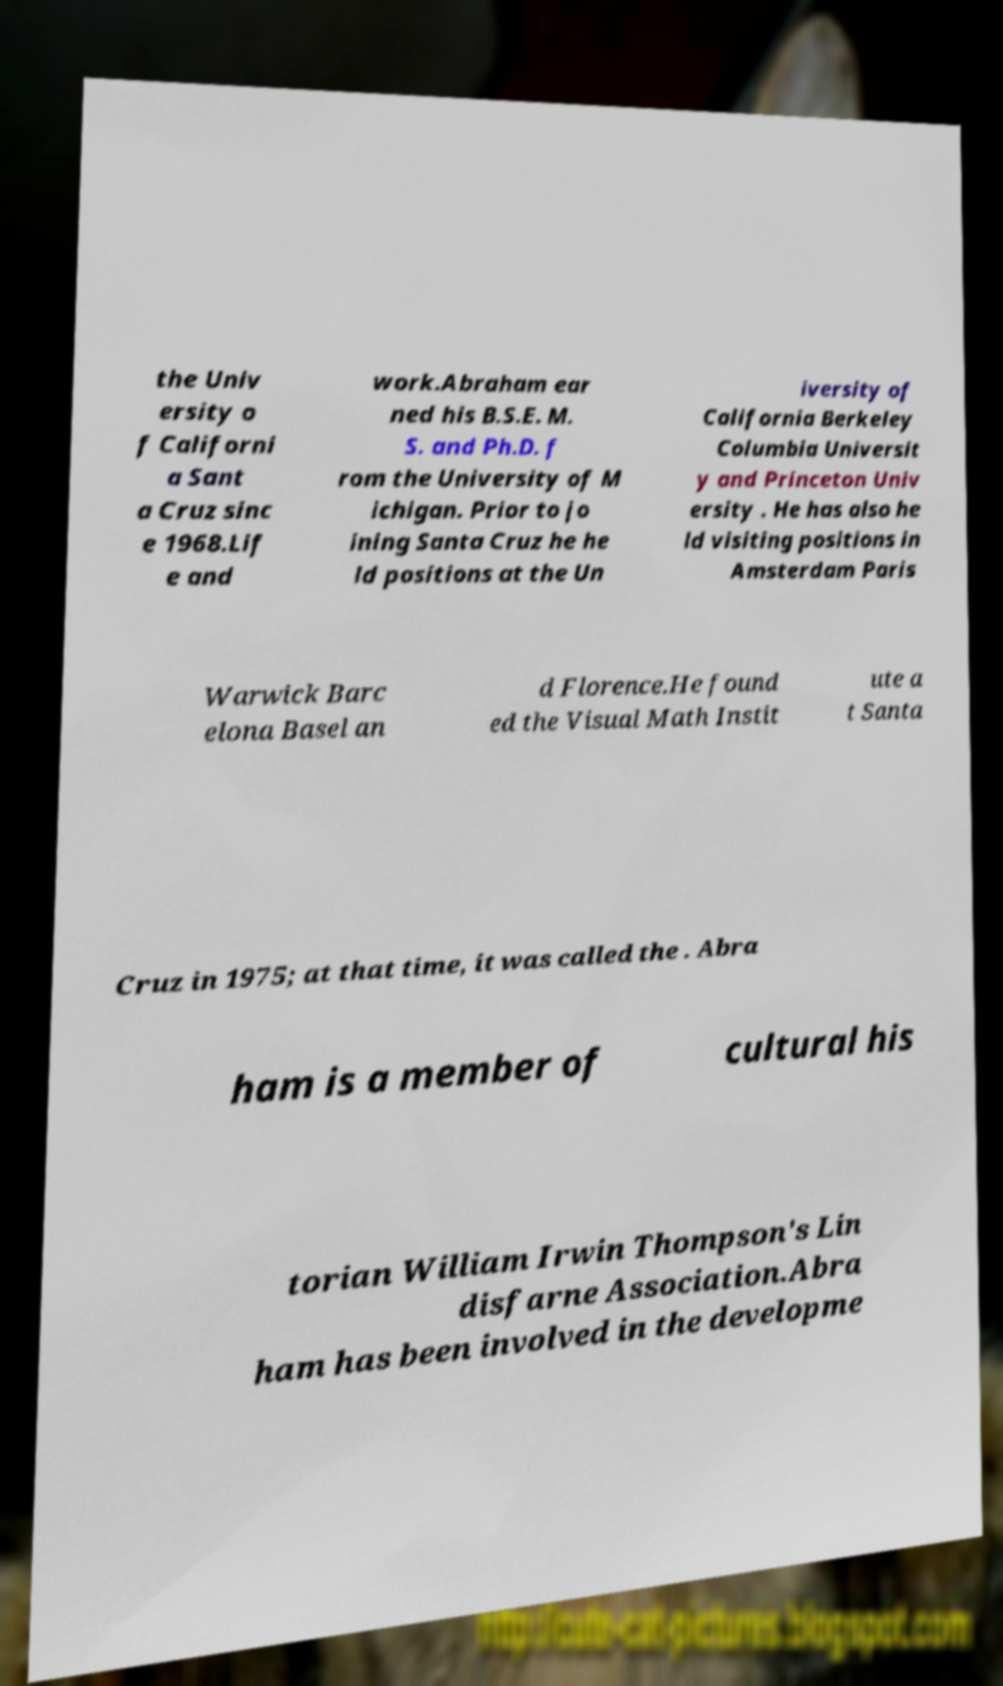Can you accurately transcribe the text from the provided image for me? the Univ ersity o f Californi a Sant a Cruz sinc e 1968.Lif e and work.Abraham ear ned his B.S.E. M. S. and Ph.D. f rom the University of M ichigan. Prior to jo ining Santa Cruz he he ld positions at the Un iversity of California Berkeley Columbia Universit y and Princeton Univ ersity . He has also he ld visiting positions in Amsterdam Paris Warwick Barc elona Basel an d Florence.He found ed the Visual Math Instit ute a t Santa Cruz in 1975; at that time, it was called the . Abra ham is a member of cultural his torian William Irwin Thompson's Lin disfarne Association.Abra ham has been involved in the developme 